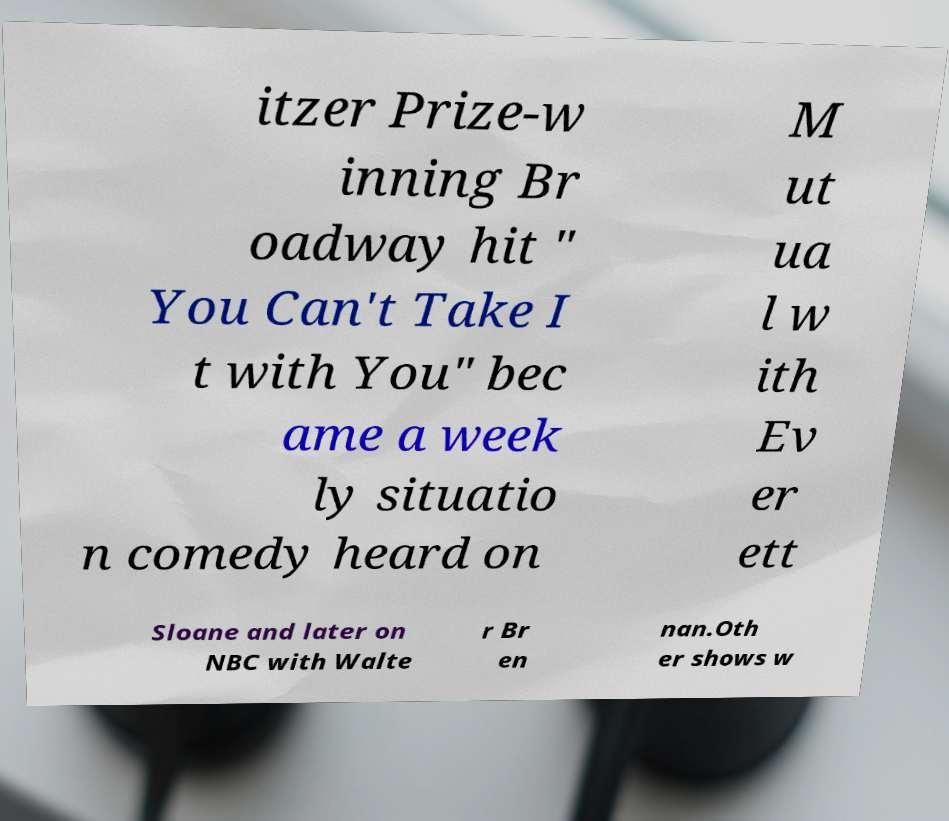Please identify and transcribe the text found in this image. itzer Prize-w inning Br oadway hit " You Can't Take I t with You" bec ame a week ly situatio n comedy heard on M ut ua l w ith Ev er ett Sloane and later on NBC with Walte r Br en nan.Oth er shows w 